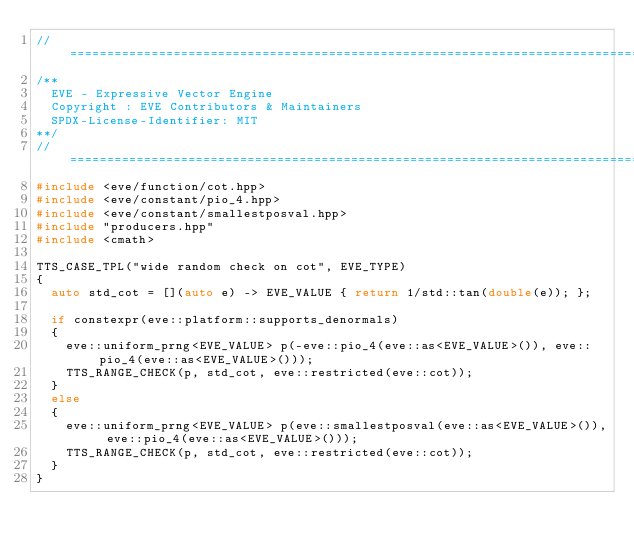Convert code to text. <code><loc_0><loc_0><loc_500><loc_500><_C++_>//==================================================================================================
/**
  EVE - Expressive Vector Engine
  Copyright : EVE Contributors & Maintainers
  SPDX-License-Identifier: MIT
**/
//==================================================================================================
#include <eve/function/cot.hpp>
#include <eve/constant/pio_4.hpp>
#include <eve/constant/smallestposval.hpp>
#include "producers.hpp"
#include <cmath>

TTS_CASE_TPL("wide random check on cot", EVE_TYPE)
{
  auto std_cot = [](auto e) -> EVE_VALUE { return 1/std::tan(double(e)); };

  if constexpr(eve::platform::supports_denormals)
  {
    eve::uniform_prng<EVE_VALUE> p(-eve::pio_4(eve::as<EVE_VALUE>()), eve::pio_4(eve::as<EVE_VALUE>()));
    TTS_RANGE_CHECK(p, std_cot, eve::restricted(eve::cot));
  }
  else
  {
    eve::uniform_prng<EVE_VALUE> p(eve::smallestposval(eve::as<EVE_VALUE>()), eve::pio_4(eve::as<EVE_VALUE>()));
    TTS_RANGE_CHECK(p, std_cot, eve::restricted(eve::cot));
  }
}
</code> 